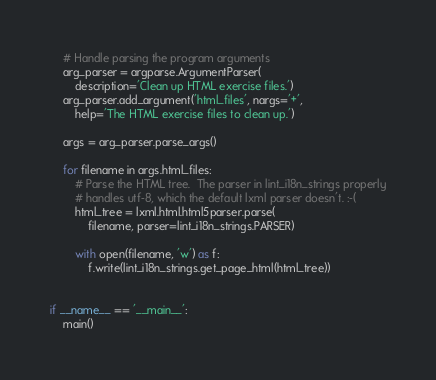Convert code to text. <code><loc_0><loc_0><loc_500><loc_500><_Python_>    # Handle parsing the program arguments
    arg_parser = argparse.ArgumentParser(
        description='Clean up HTML exercise files.')
    arg_parser.add_argument('html_files', nargs='+',
        help='The HTML exercise files to clean up.')

    args = arg_parser.parse_args()

    for filename in args.html_files:
        # Parse the HTML tree.  The parser in lint_i18n_strings properly
        # handles utf-8, which the default lxml parser doesn't. :-(
        html_tree = lxml.html.html5parser.parse(
            filename, parser=lint_i18n_strings.PARSER)

        with open(filename, 'w') as f:
            f.write(lint_i18n_strings.get_page_html(html_tree))


if __name__ == '__main__':
    main()
</code> 